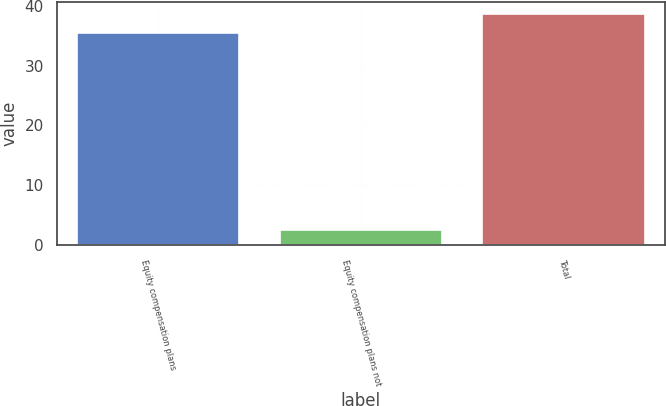Convert chart to OTSL. <chart><loc_0><loc_0><loc_500><loc_500><bar_chart><fcel>Equity compensation plans<fcel>Equity compensation plans not<fcel>Total<nl><fcel>35.42<fcel>2.53<fcel>38.71<nl></chart> 